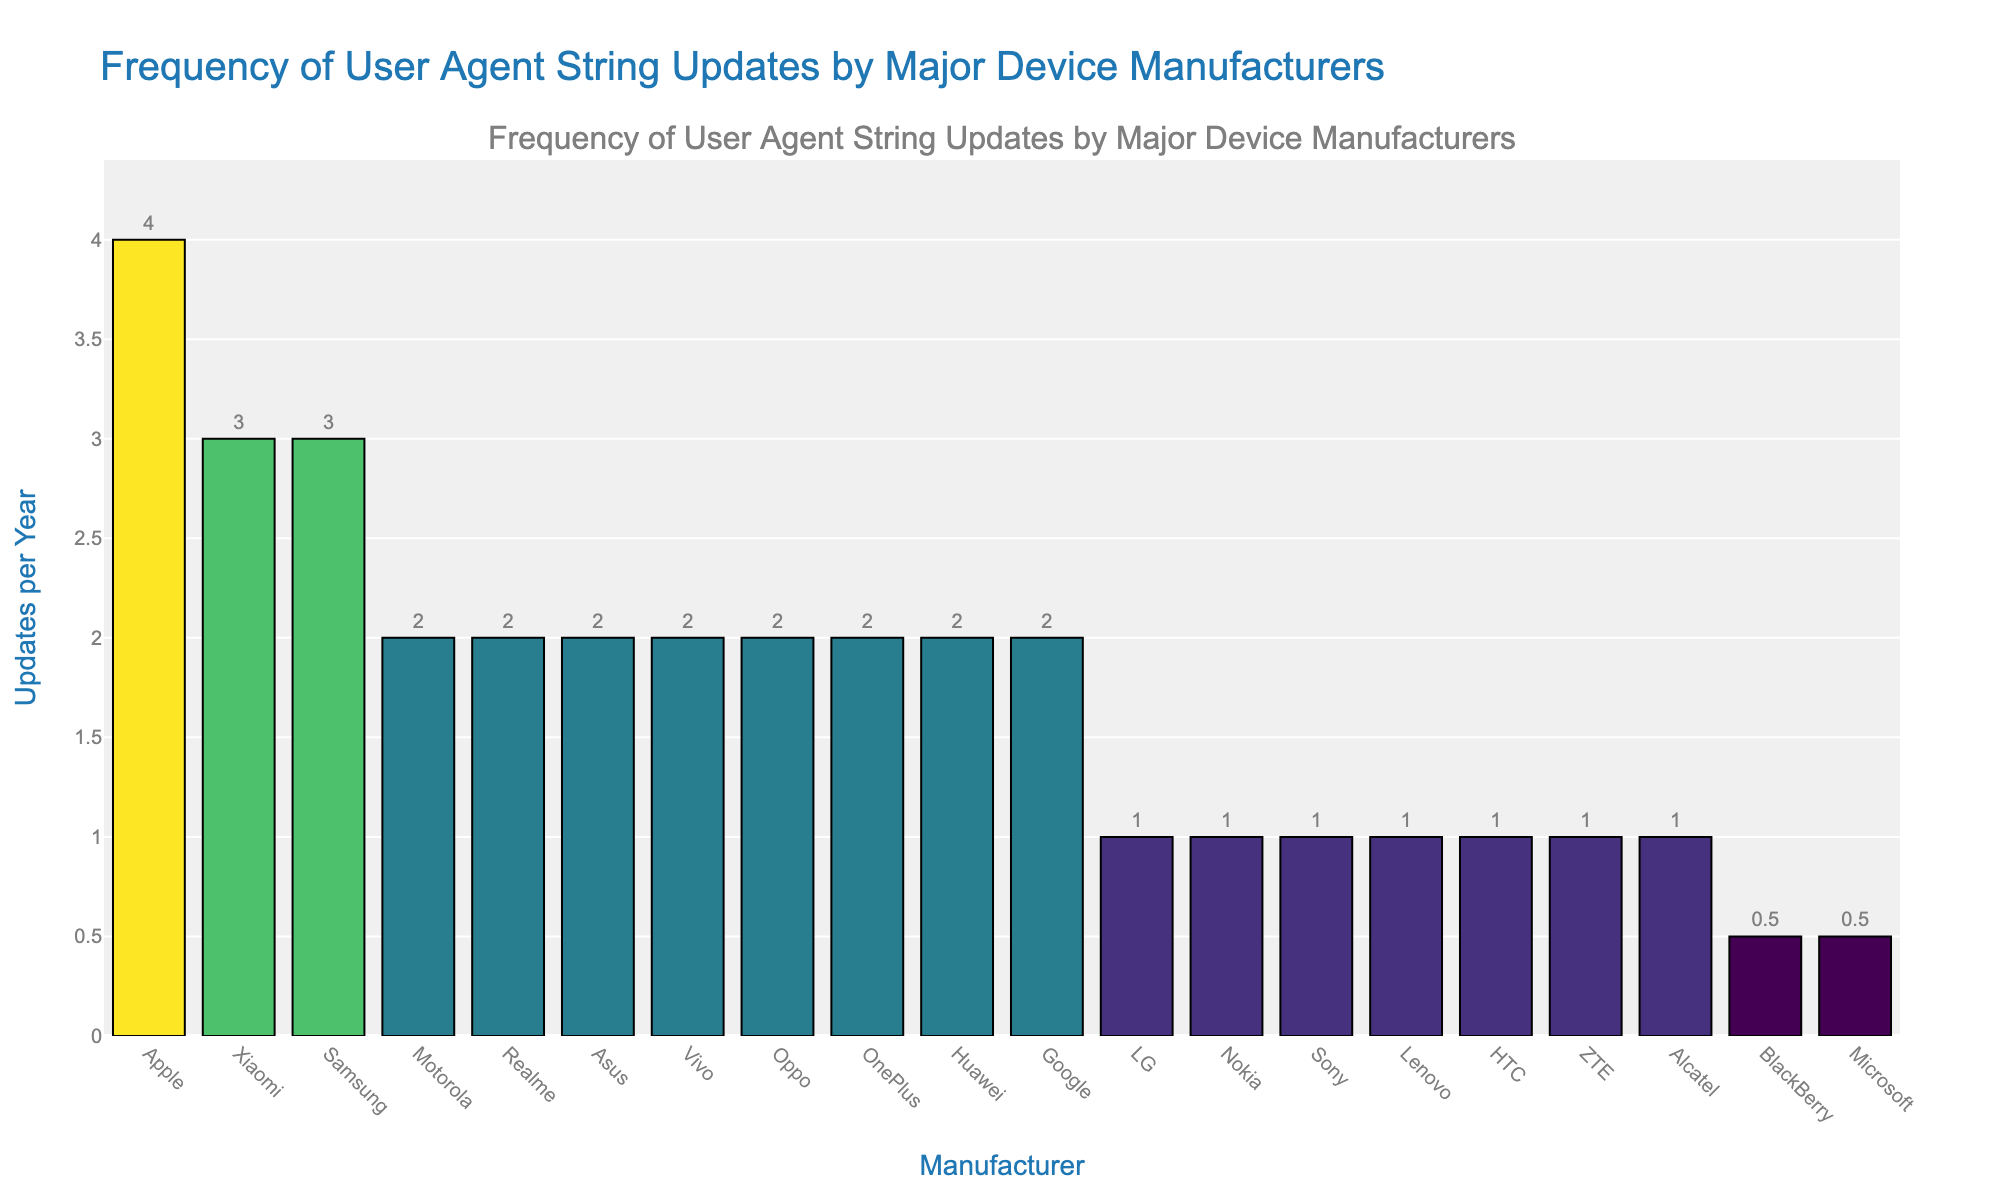Which manufacturer updates their user agent strings the most frequently? By looking at the height of the bars, Apple has the highest bar in the chart, indicating they update their user agent strings the most often.
Answer: Apple Which manufacturers update user agent strings only once per year? The bars corresponding to Sony, LG, Nokia, Lenovo, ZTE, Alcatel, and HTC all reach the height marking 1 update per year.
Answer: Sony, LG, Nokia, Lenovo, ZTE, Alcatel, HTC How many manufacturers update user agent strings more frequently than Google? Google has 2 updates per year. The manufacturers with higher updates are Apple (4), Samsung (3), and Xiaomi (3), totaling 3 manufacturers.
Answer: 3 Which manufacturer has the least frequent user agent string updates? BlackBerry and Microsoft have the lowest bars, each reaching only 0.5 updates per year.
Answer: BlackBerry, Microsoft What is the total number of updates per year for all manufacturers updating more than once a year? Summing updates for manufacturers with more than one update: Apple (4), Samsung (3), Xiaomi (3), Google (2), Huawei (2), OnePlus (2), Motorola (2), Oppo (2), Vivo (2), Asus (2), Realme (2). Total = 4+3+3+2+2+2+2+2+2+2+2 = 28
Answer: 28 Which manufacturer has exactly double the number of updates per year as Lenovo? Lenovo has 1 update per year. Double that is 2. Manufacturers with 2 updates are Google, Huawei, OnePlus, Motorola, Oppo, Vivo, Asus, Realme.
Answer: Google, Huawei, OnePlus, Motorola, Oppo, Vivo, Asus, Realme Is there a significant gap between any two adjacent bars in terms of updates per year? The largest gap between adjacent bars is between Apple (4) and the next highest, Samsung and Xiaomi (both 3), which is a gap of 1 update per year.
Answer: Yes, between Apple and Samsung/Xiaomi What is the average number of updates per year across all manufacturers? Sum of updates per year (4+3+2+2+3+2+1+1+2+1+2+2+1+2+1+0.5+0.5+1+2+1) is 35. Number of manufacturers is 20. Average = 35/20 = 1.75
Answer: 1.75 Which manufacturers update their user agent strings with the same frequency as Motorola? Motorola has 2 updates per year. The manufacturers with the same number of updates are Google, Huawei, OnePlus, Oppo, Vivo, Asus, Realme.
Answer: Google, Huawei, OnePlus, Oppo, Vivo, Asus, Realme 